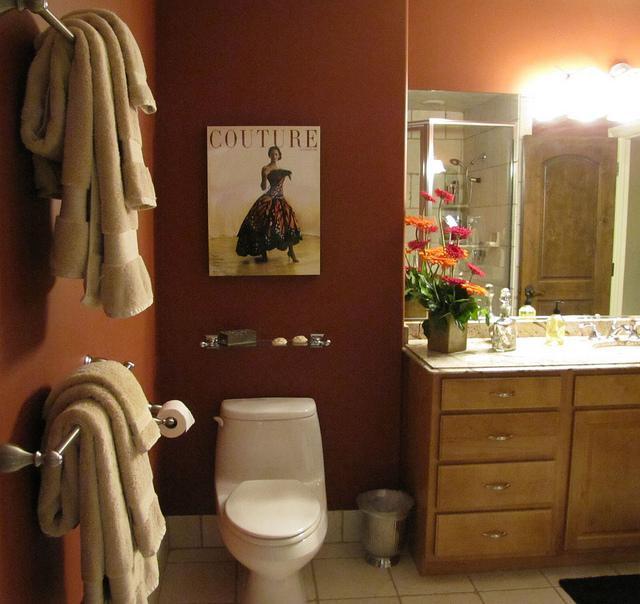How many horses are in this photo?
Give a very brief answer. 0. 